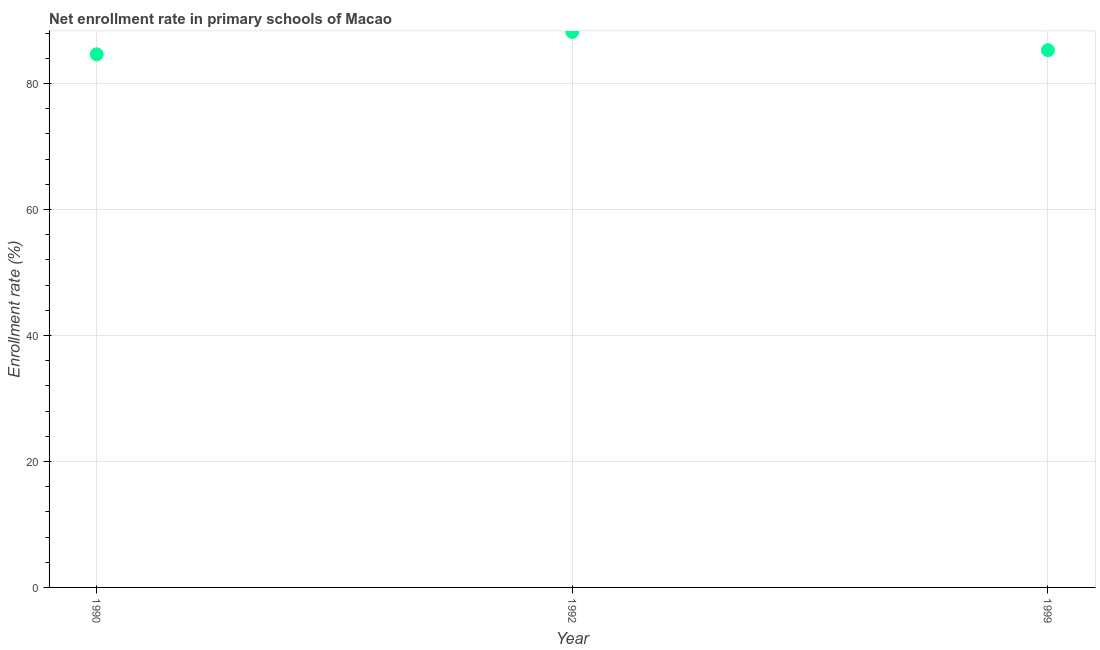What is the net enrollment rate in primary schools in 1992?
Give a very brief answer. 88.19. Across all years, what is the maximum net enrollment rate in primary schools?
Give a very brief answer. 88.19. Across all years, what is the minimum net enrollment rate in primary schools?
Ensure brevity in your answer.  84.64. In which year was the net enrollment rate in primary schools maximum?
Provide a short and direct response. 1992. In which year was the net enrollment rate in primary schools minimum?
Keep it short and to the point. 1990. What is the sum of the net enrollment rate in primary schools?
Make the answer very short. 258.12. What is the difference between the net enrollment rate in primary schools in 1990 and 1999?
Make the answer very short. -0.66. What is the average net enrollment rate in primary schools per year?
Provide a short and direct response. 86.04. What is the median net enrollment rate in primary schools?
Offer a terse response. 85.3. In how many years, is the net enrollment rate in primary schools greater than 76 %?
Ensure brevity in your answer.  3. What is the ratio of the net enrollment rate in primary schools in 1992 to that in 1999?
Offer a terse response. 1.03. Is the difference between the net enrollment rate in primary schools in 1990 and 1992 greater than the difference between any two years?
Your answer should be very brief. Yes. What is the difference between the highest and the second highest net enrollment rate in primary schools?
Your response must be concise. 2.89. Is the sum of the net enrollment rate in primary schools in 1990 and 1992 greater than the maximum net enrollment rate in primary schools across all years?
Give a very brief answer. Yes. What is the difference between the highest and the lowest net enrollment rate in primary schools?
Provide a succinct answer. 3.55. What is the difference between two consecutive major ticks on the Y-axis?
Provide a succinct answer. 20. Does the graph contain any zero values?
Your answer should be very brief. No. Does the graph contain grids?
Provide a short and direct response. Yes. What is the title of the graph?
Your answer should be very brief. Net enrollment rate in primary schools of Macao. What is the label or title of the Y-axis?
Your answer should be very brief. Enrollment rate (%). What is the Enrollment rate (%) in 1990?
Offer a terse response. 84.64. What is the Enrollment rate (%) in 1992?
Provide a succinct answer. 88.19. What is the Enrollment rate (%) in 1999?
Give a very brief answer. 85.3. What is the difference between the Enrollment rate (%) in 1990 and 1992?
Provide a succinct answer. -3.55. What is the difference between the Enrollment rate (%) in 1990 and 1999?
Ensure brevity in your answer.  -0.66. What is the difference between the Enrollment rate (%) in 1992 and 1999?
Keep it short and to the point. 2.89. What is the ratio of the Enrollment rate (%) in 1992 to that in 1999?
Offer a very short reply. 1.03. 